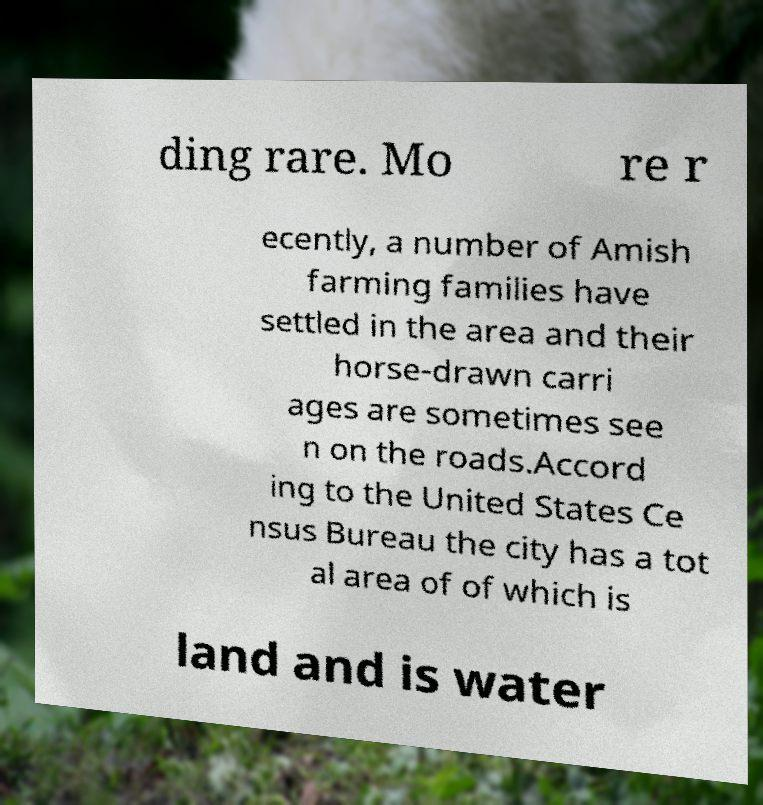For documentation purposes, I need the text within this image transcribed. Could you provide that? ding rare. Mo re r ecently, a number of Amish farming families have settled in the area and their horse-drawn carri ages are sometimes see n on the roads.Accord ing to the United States Ce nsus Bureau the city has a tot al area of of which is land and is water 